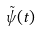Convert formula to latex. <formula><loc_0><loc_0><loc_500><loc_500>\tilde { \psi } ( t )</formula> 